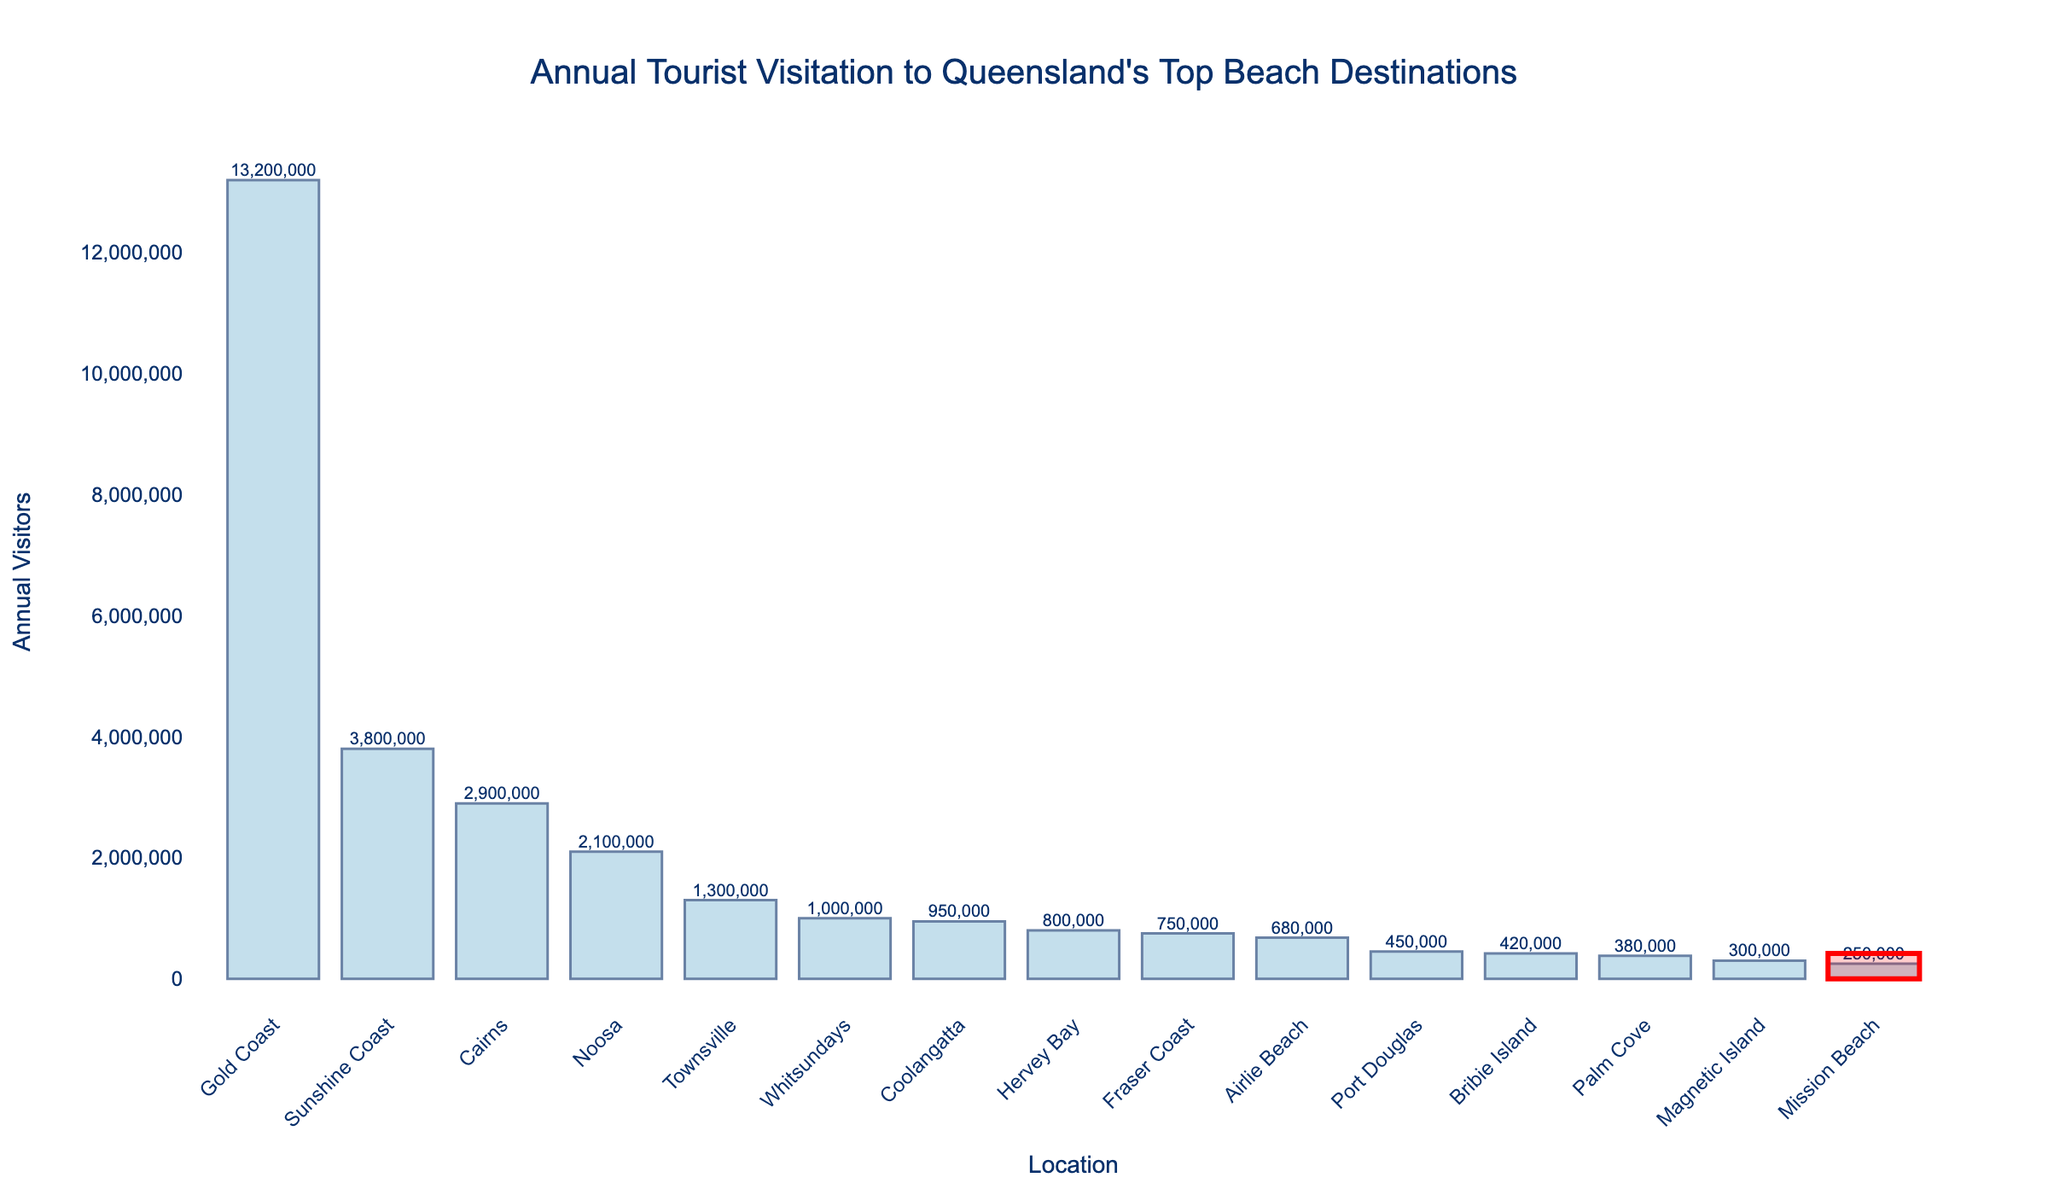What is the total number of annual visitors to the top five beach destinations? Identify the top five beach destinations by annual visitors: Gold Coast (13,200,000), Sunshine Coast (3,800,000), Cairns (2,900,000), Noosa (2,100,000), and Townsville (1,300,000). Sum these values: 13,200,000 + 3,800,000 + 2,900,000 + 2,100,000 + 1,300,000 = 23,300,000.
Answer: 23,300,000 Which location has the highest annual tourist visitation? Look at the figure to find the bar with the greatest height, which represents the location with the highest number of annual visitors. The highest bar corresponds to the Gold Coast.
Answer: Gold Coast How many more visitors does the Gold Coast receive compared to the Sunshine Coast? Identify the annual visitors for the Gold Coast (13,200,000) and the Sunshine Coast (3,800,000). Subtract the Sunshine Coast's visitors from the Gold Coast's visitors: 13,200,000 - 3,800,000 = 9,400,000.
Answer: 9,400,000 What is the average annual visitation to be the top three destinations? Identify the top three destinations: Gold Coast (13,200,000), Sunshine Coast (3,800,000), and Cairns (2,900,000). Sum these values and divide by 3: (13,200,000 + 3,800,000 + 2,900,000) / 3 = 6,633,333.33.
Answer: 6,633,333.33 Which location has the smallest number of annual visitors? Look at the figure to find the bar with the smallest height, which represents the location with the fewest number of annual visitors. The smallest bar corresponds to Mission Beach.
Answer: Mission Beach Is Bribie Island visited more or less frequently compared to Airlie Beach? Locate the bars representing Bribie Island (420,000 visitors) and Airlie Beach (680,000 visitors). Compare their heights; Bribie Island's bar is shorter than Airlie Beach's.
Answer: Less frequently What is the range of annual visitors among all listed locations? Identify the locations with the maximum and minimum number of annual visitors: Gold Coast (13,200,000) and Mission Beach (250,000). Subtract the minimum from the maximum: 13,200,000 - 250,000 = 12,950,000.
Answer: 12,950,000 What is the median number of annual visitors among the listed locations? List the number of annual visitors in ascending order: 250,000, 300,000, 380,000, 420,000, 450,000, 680,000, 750,000, 800,000, 950,000, 1,000,000, 1,300,000, 2,100,000, 2,900,000, 3,800,000, 13,200,000. Since there are 15 locations, the median is the 8th value: 800,000.
Answer: 800,000 